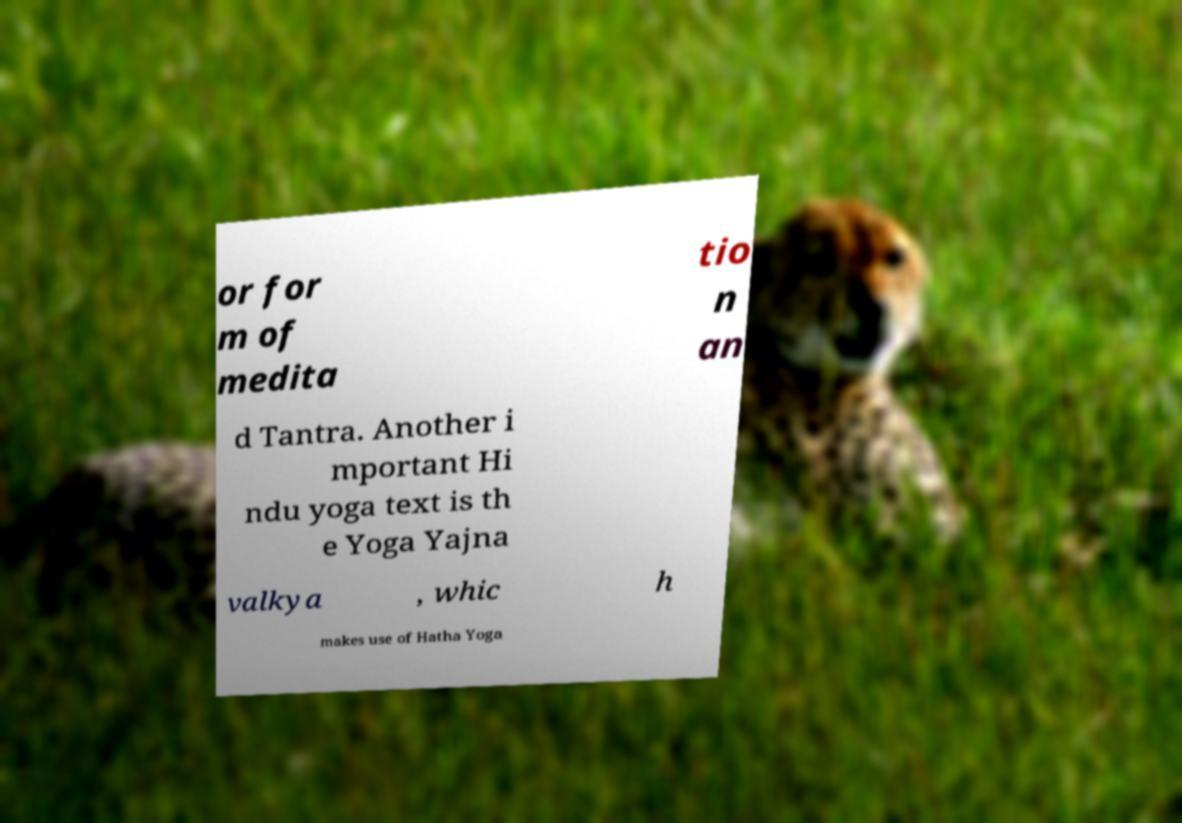I need the written content from this picture converted into text. Can you do that? or for m of medita tio n an d Tantra. Another i mportant Hi ndu yoga text is th e Yoga Yajna valkya , whic h makes use of Hatha Yoga 